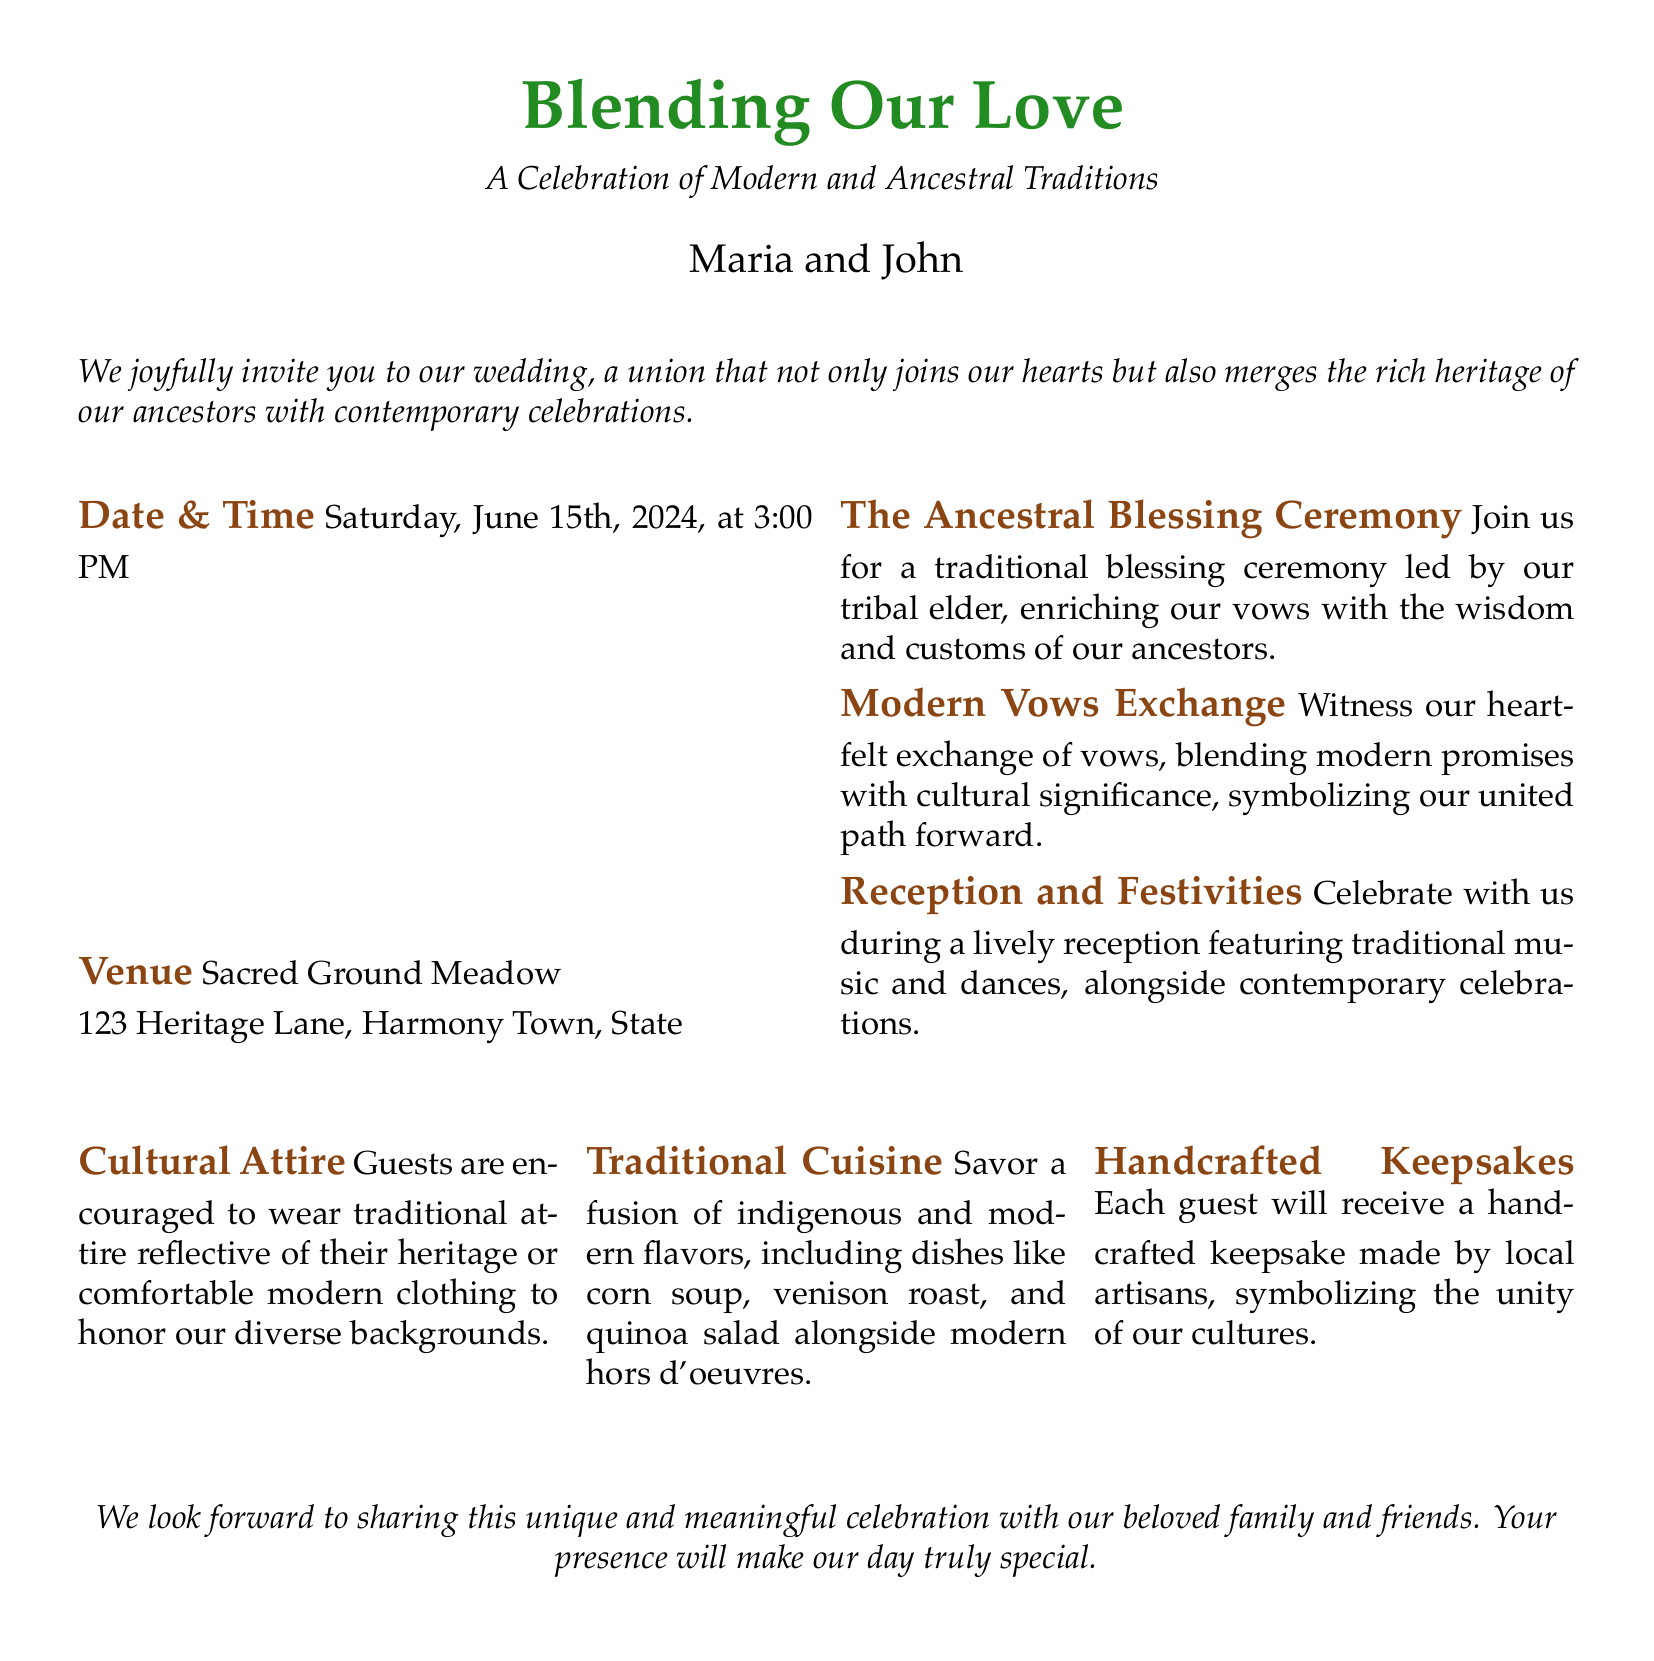What is the wedding date? The wedding date is specified in the document as Saturday, June 15th, 2024.
Answer: Saturday, June 15th, 2024 Who are the couple getting married? The document introduces the couple getting married as Maria and John.
Answer: Maria and John What is the venue of the wedding? The venue is detailed in the document as Sacred Ground Meadow, located at 123 Heritage Lane, Harmony Town, State.
Answer: Sacred Ground Meadow What is the purpose of the Ancestral Blessing Ceremony? The document describes the Ancestral Blessing Ceremony as enriching the vows with wisdom and customs of the ancestors led by a tribal elder.
Answer: Enriching the vows with wisdom and customs What type of cuisine will be served at the reception? The cuisine mentioned in the document includes a fusion of indigenous and modern flavors, like corn soup and venison roast.
Answer: Fusion of indigenous and modern flavors What attire is encouraged for the guests? The document mentions that guests are encouraged to wear traditional attire reflective of their heritage or comfortable modern clothing.
Answer: Traditional attire or comfortable modern clothing What is a unique feature of this wedding invitation? The unique feature is the blending of modern and ancestral traditions in both the ceremony and celebration as highlighted throughout the invitation.
Answer: Blending of modern and ancestral traditions What type of keepsakes will guests receive? The document states that each guest will receive a handcrafted keepsake made by local artisans.
Answer: Handcrafted keepsake How many sections are there for guest information? There are three main sections providing essential information for guests.
Answer: Three sections 